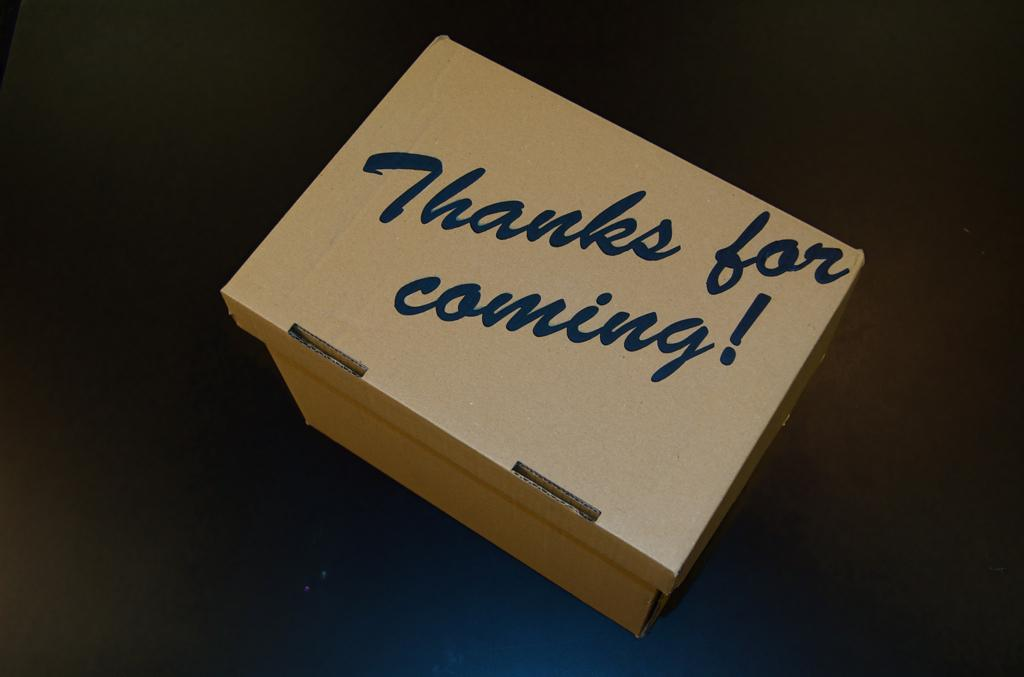<image>
Render a clear and concise summary of the photo. A brown box that has thanks for coming on it 